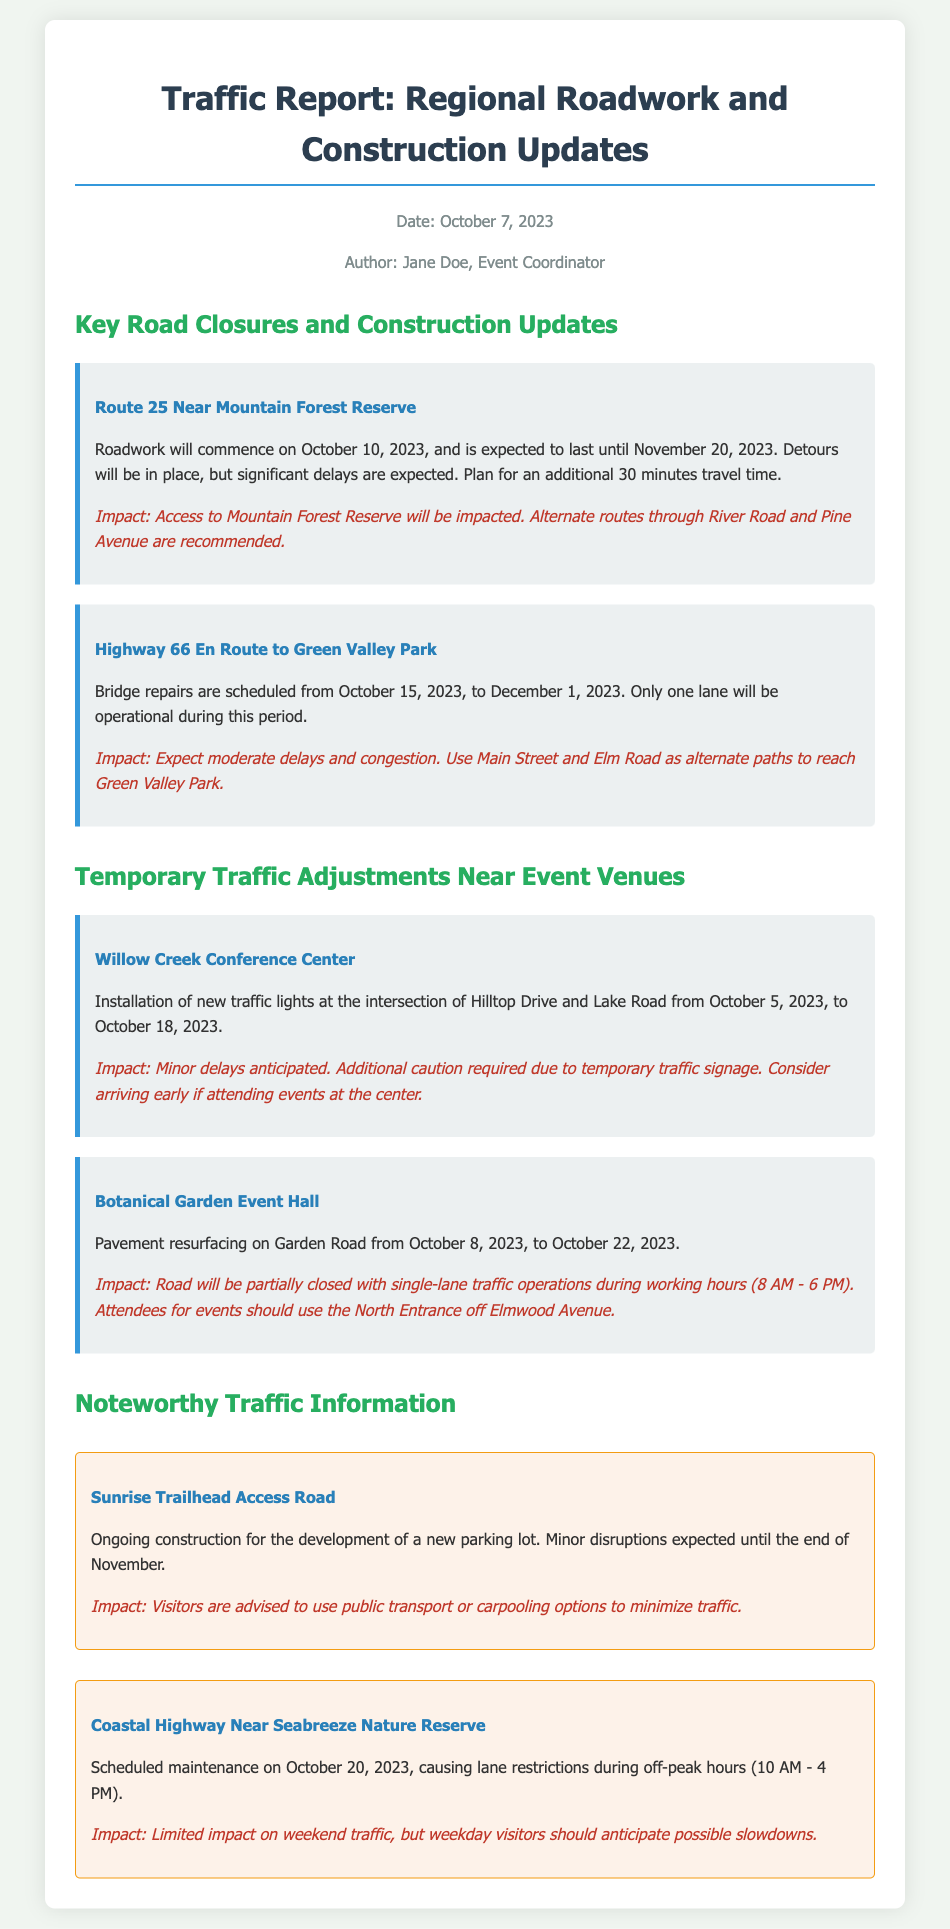What is the start date for roadwork on Route 25? The roadwork on Route 25 is set to commence on October 10, 2023, as stated in the document.
Answer: October 10, 2023 How long is the roadwork on Route 25 expected to last? According to the document, the roadwork is expected to last until November 20, 2023.
Answer: Until November 20, 2023 What alternate routes are recommended for accessing Mountain Forest Reserve? The document recommends using River Road and Pine Avenue as alternate routes due to roadwork on Route 25.
Answer: River Road and Pine Avenue What is the expected travel time delay for Route 25? The document mentions planning for an additional 30 minutes of travel time due to the roadwork.
Answer: 30 minutes What type of repairs are scheduled on Highway 66? The document specifies that bridge repairs are scheduled on Highway 66, affecting access to Green Valley Park.
Answer: Bridge repairs What is the impact of pavement resurfacing on Garden Road for attendees? The document indicates that road users should use the North Entrance off Elmwood Avenue due to partial closures.
Answer: Use the North Entrance off Elmwood Avenue What is the duration of the installation of traffic lights at Willow Creek Conference Center? The installation of new traffic lights is scheduled from October 5, 2023, to October 18, 2023, as per the document.
Answer: October 5, 2023, to October 18, 2023 When is maintenance scheduled for Coastal Highway near Seabreeze Nature Reserve? The document states that maintenance is scheduled on October 20, 2023.
Answer: October 20, 2023 What should visitors do to minimize traffic at Sunrise Trailhead Access Road? Visitors are advised to use public transport or carpooling options to minimize traffic according to the document.
Answer: Use public transport or carpooling options 